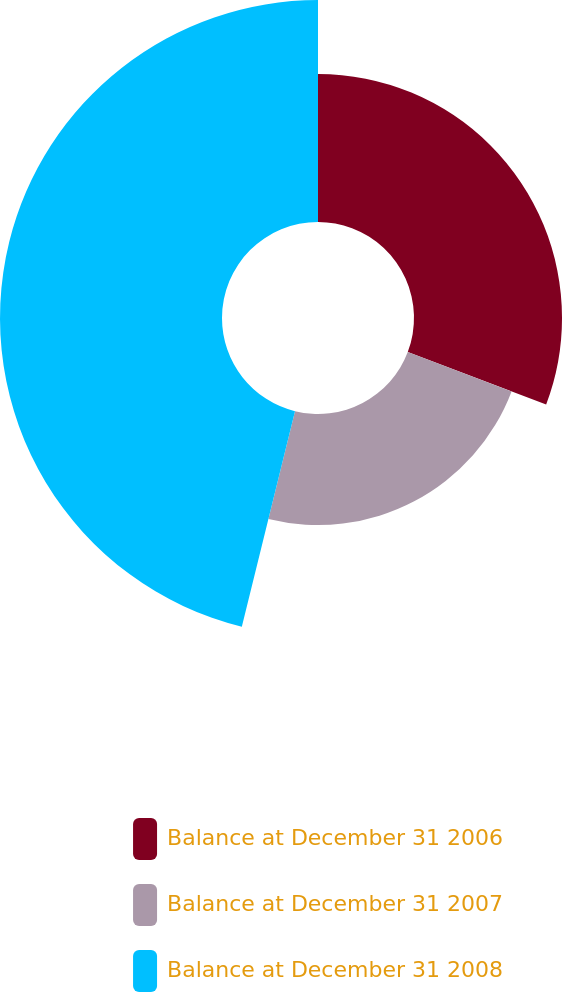<chart> <loc_0><loc_0><loc_500><loc_500><pie_chart><fcel>Balance at December 31 2006<fcel>Balance at December 31 2007<fcel>Balance at December 31 2008<nl><fcel>30.77%<fcel>23.08%<fcel>46.15%<nl></chart> 